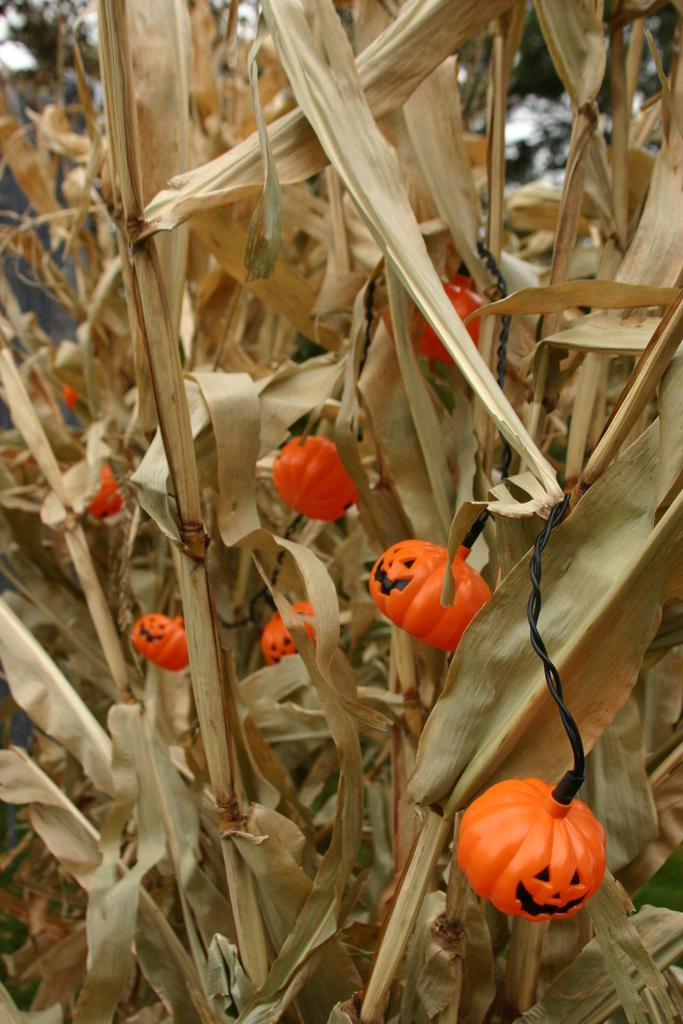What type of plants are in the image? There are dry plants with dry leaves in the image. Are there any additional elements present among the plants? Yes, there are decorative lights in between the plants. What type of amusement can be seen in the image? There is no amusement present in the image; it features dry plants with dry leaves and decorative lights. How does the head of the plant move in the image? The image does not depict a plant with a head, and even if it did, plants do not have the ability to move their heads. 